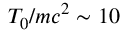Convert formula to latex. <formula><loc_0><loc_0><loc_500><loc_500>T _ { 0 } / m c ^ { 2 } \sim 1 0</formula> 